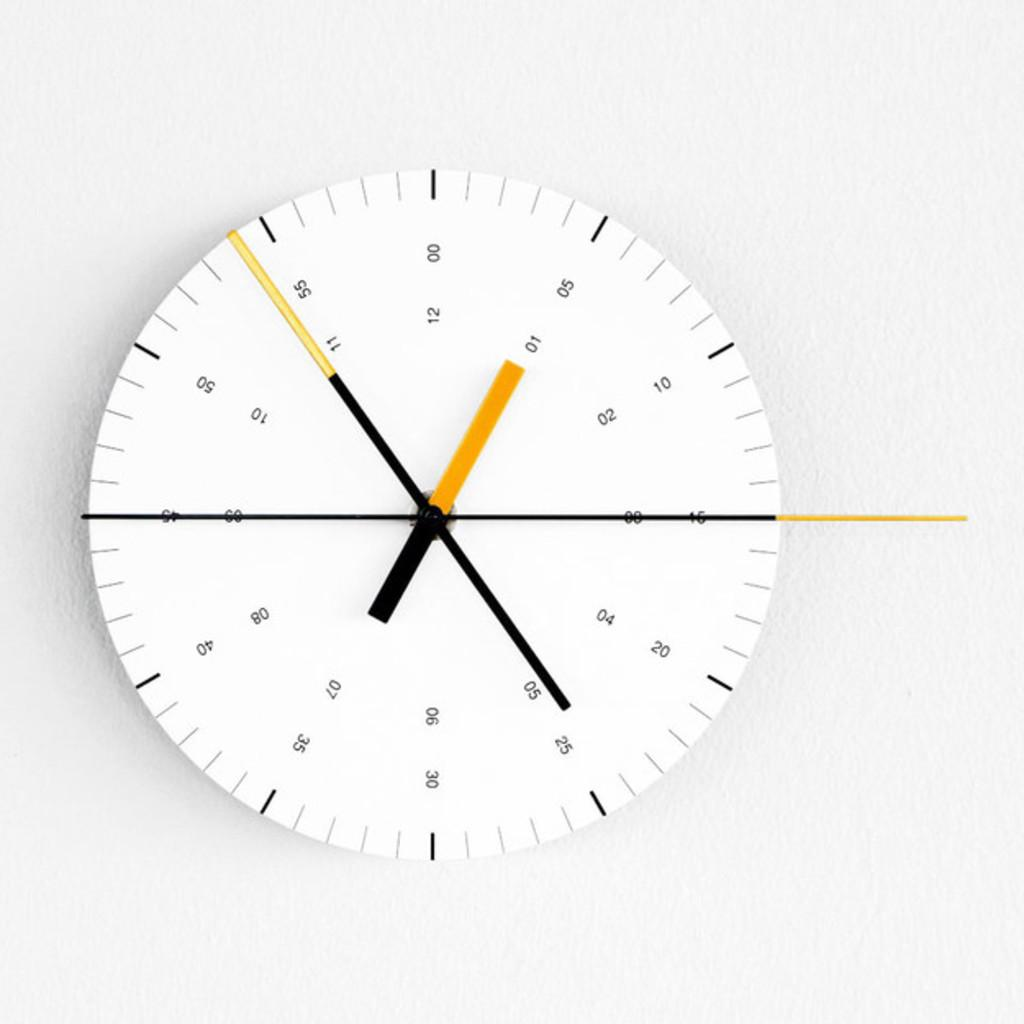<image>
Render a clear and concise summary of the photo. A white clock with a black and yellow time hands and the number 1 thru 12. 